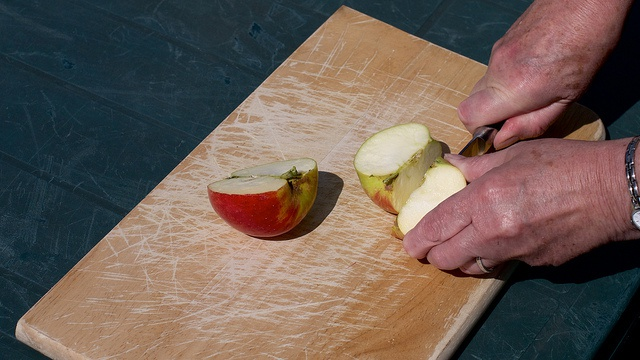Describe the objects in this image and their specific colors. I can see dining table in darkblue, navy, and gray tones, people in darkblue, brown, maroon, and salmon tones, apple in darkblue, beige, tan, and brown tones, apple in darkblue, maroon, darkgray, and olive tones, and knife in darkblue, black, maroon, and brown tones in this image. 